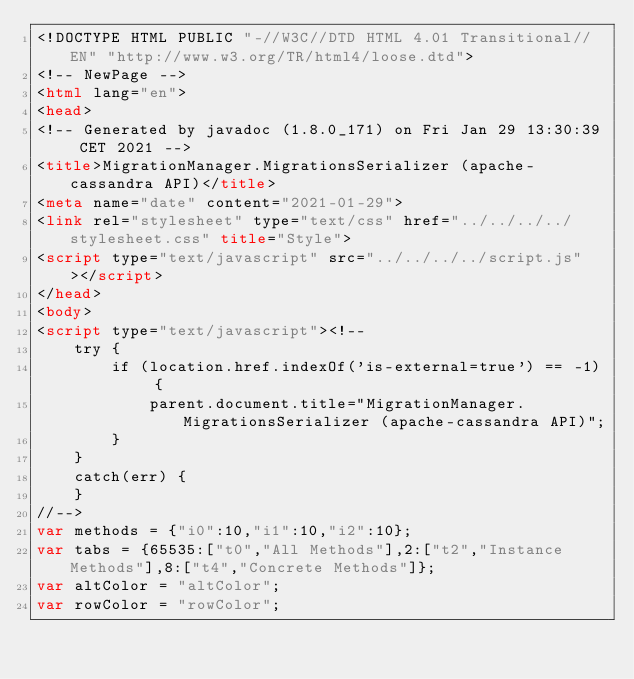<code> <loc_0><loc_0><loc_500><loc_500><_HTML_><!DOCTYPE HTML PUBLIC "-//W3C//DTD HTML 4.01 Transitional//EN" "http://www.w3.org/TR/html4/loose.dtd">
<!-- NewPage -->
<html lang="en">
<head>
<!-- Generated by javadoc (1.8.0_171) on Fri Jan 29 13:30:39 CET 2021 -->
<title>MigrationManager.MigrationsSerializer (apache-cassandra API)</title>
<meta name="date" content="2021-01-29">
<link rel="stylesheet" type="text/css" href="../../../../stylesheet.css" title="Style">
<script type="text/javascript" src="../../../../script.js"></script>
</head>
<body>
<script type="text/javascript"><!--
    try {
        if (location.href.indexOf('is-external=true') == -1) {
            parent.document.title="MigrationManager.MigrationsSerializer (apache-cassandra API)";
        }
    }
    catch(err) {
    }
//-->
var methods = {"i0":10,"i1":10,"i2":10};
var tabs = {65535:["t0","All Methods"],2:["t2","Instance Methods"],8:["t4","Concrete Methods"]};
var altColor = "altColor";
var rowColor = "rowColor";</code> 